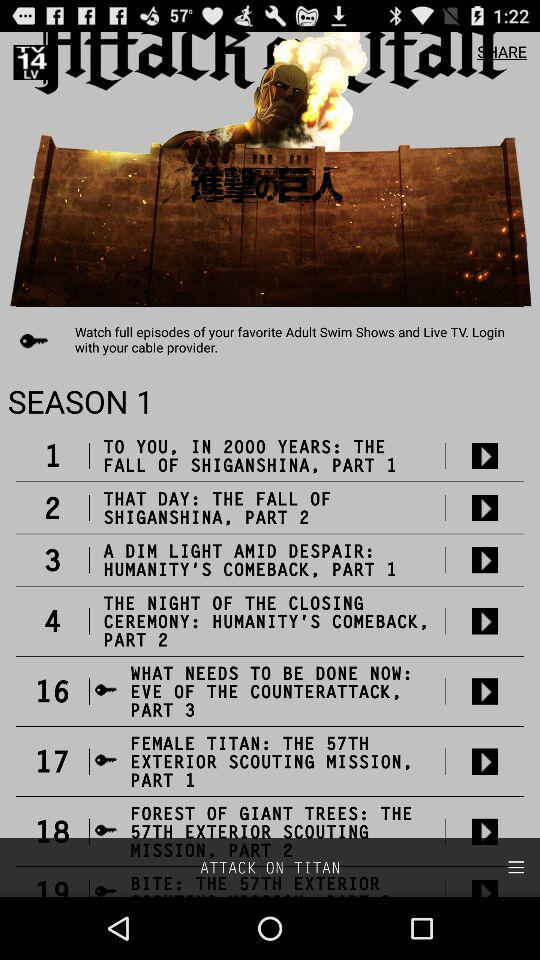How many episodes are in season 1 of Attack on Titan?
Answer the question using a single word or phrase. 19 